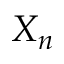<formula> <loc_0><loc_0><loc_500><loc_500>X _ { n }</formula> 